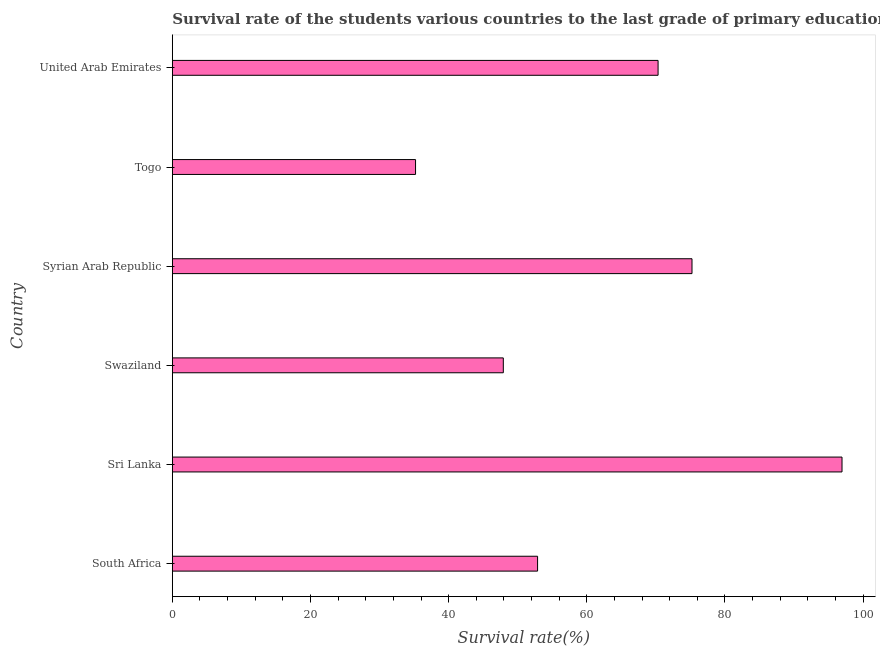Does the graph contain any zero values?
Ensure brevity in your answer.  No. What is the title of the graph?
Offer a terse response. Survival rate of the students various countries to the last grade of primary education. What is the label or title of the X-axis?
Your response must be concise. Survival rate(%). What is the label or title of the Y-axis?
Give a very brief answer. Country. What is the survival rate in primary education in Syrian Arab Republic?
Your answer should be very brief. 75.23. Across all countries, what is the maximum survival rate in primary education?
Offer a terse response. 96.94. Across all countries, what is the minimum survival rate in primary education?
Offer a very short reply. 35.21. In which country was the survival rate in primary education maximum?
Ensure brevity in your answer.  Sri Lanka. In which country was the survival rate in primary education minimum?
Make the answer very short. Togo. What is the sum of the survival rate in primary education?
Keep it short and to the point. 378.48. What is the difference between the survival rate in primary education in Syrian Arab Republic and Togo?
Give a very brief answer. 40.02. What is the average survival rate in primary education per country?
Provide a short and direct response. 63.08. What is the median survival rate in primary education?
Ensure brevity in your answer.  61.59. In how many countries, is the survival rate in primary education greater than 28 %?
Make the answer very short. 6. What is the ratio of the survival rate in primary education in South Africa to that in Swaziland?
Provide a short and direct response. 1.1. Is the difference between the survival rate in primary education in Swaziland and Togo greater than the difference between any two countries?
Provide a succinct answer. No. What is the difference between the highest and the second highest survival rate in primary education?
Provide a succinct answer. 21.72. What is the difference between the highest and the lowest survival rate in primary education?
Your response must be concise. 61.74. In how many countries, is the survival rate in primary education greater than the average survival rate in primary education taken over all countries?
Make the answer very short. 3. What is the difference between two consecutive major ticks on the X-axis?
Your answer should be compact. 20. Are the values on the major ticks of X-axis written in scientific E-notation?
Keep it short and to the point. No. What is the Survival rate(%) in South Africa?
Ensure brevity in your answer.  52.87. What is the Survival rate(%) of Sri Lanka?
Your response must be concise. 96.94. What is the Survival rate(%) in Swaziland?
Ensure brevity in your answer.  47.91. What is the Survival rate(%) in Syrian Arab Republic?
Your response must be concise. 75.23. What is the Survival rate(%) of Togo?
Your answer should be very brief. 35.21. What is the Survival rate(%) in United Arab Emirates?
Ensure brevity in your answer.  70.32. What is the difference between the Survival rate(%) in South Africa and Sri Lanka?
Ensure brevity in your answer.  -44.07. What is the difference between the Survival rate(%) in South Africa and Swaziland?
Provide a short and direct response. 4.96. What is the difference between the Survival rate(%) in South Africa and Syrian Arab Republic?
Make the answer very short. -22.36. What is the difference between the Survival rate(%) in South Africa and Togo?
Provide a succinct answer. 17.67. What is the difference between the Survival rate(%) in South Africa and United Arab Emirates?
Offer a very short reply. -17.45. What is the difference between the Survival rate(%) in Sri Lanka and Swaziland?
Ensure brevity in your answer.  49.03. What is the difference between the Survival rate(%) in Sri Lanka and Syrian Arab Republic?
Provide a succinct answer. 21.72. What is the difference between the Survival rate(%) in Sri Lanka and Togo?
Offer a terse response. 61.74. What is the difference between the Survival rate(%) in Sri Lanka and United Arab Emirates?
Give a very brief answer. 26.63. What is the difference between the Survival rate(%) in Swaziland and Syrian Arab Republic?
Provide a succinct answer. -27.32. What is the difference between the Survival rate(%) in Swaziland and Togo?
Your answer should be very brief. 12.71. What is the difference between the Survival rate(%) in Swaziland and United Arab Emirates?
Provide a short and direct response. -22.41. What is the difference between the Survival rate(%) in Syrian Arab Republic and Togo?
Offer a very short reply. 40.02. What is the difference between the Survival rate(%) in Syrian Arab Republic and United Arab Emirates?
Offer a terse response. 4.91. What is the difference between the Survival rate(%) in Togo and United Arab Emirates?
Make the answer very short. -35.11. What is the ratio of the Survival rate(%) in South Africa to that in Sri Lanka?
Offer a very short reply. 0.55. What is the ratio of the Survival rate(%) in South Africa to that in Swaziland?
Provide a short and direct response. 1.1. What is the ratio of the Survival rate(%) in South Africa to that in Syrian Arab Republic?
Keep it short and to the point. 0.7. What is the ratio of the Survival rate(%) in South Africa to that in Togo?
Your answer should be very brief. 1.5. What is the ratio of the Survival rate(%) in South Africa to that in United Arab Emirates?
Ensure brevity in your answer.  0.75. What is the ratio of the Survival rate(%) in Sri Lanka to that in Swaziland?
Provide a succinct answer. 2.02. What is the ratio of the Survival rate(%) in Sri Lanka to that in Syrian Arab Republic?
Provide a succinct answer. 1.29. What is the ratio of the Survival rate(%) in Sri Lanka to that in Togo?
Offer a very short reply. 2.75. What is the ratio of the Survival rate(%) in Sri Lanka to that in United Arab Emirates?
Your answer should be compact. 1.38. What is the ratio of the Survival rate(%) in Swaziland to that in Syrian Arab Republic?
Provide a short and direct response. 0.64. What is the ratio of the Survival rate(%) in Swaziland to that in Togo?
Your response must be concise. 1.36. What is the ratio of the Survival rate(%) in Swaziland to that in United Arab Emirates?
Your answer should be very brief. 0.68. What is the ratio of the Survival rate(%) in Syrian Arab Republic to that in Togo?
Keep it short and to the point. 2.14. What is the ratio of the Survival rate(%) in Syrian Arab Republic to that in United Arab Emirates?
Offer a terse response. 1.07. What is the ratio of the Survival rate(%) in Togo to that in United Arab Emirates?
Offer a terse response. 0.5. 